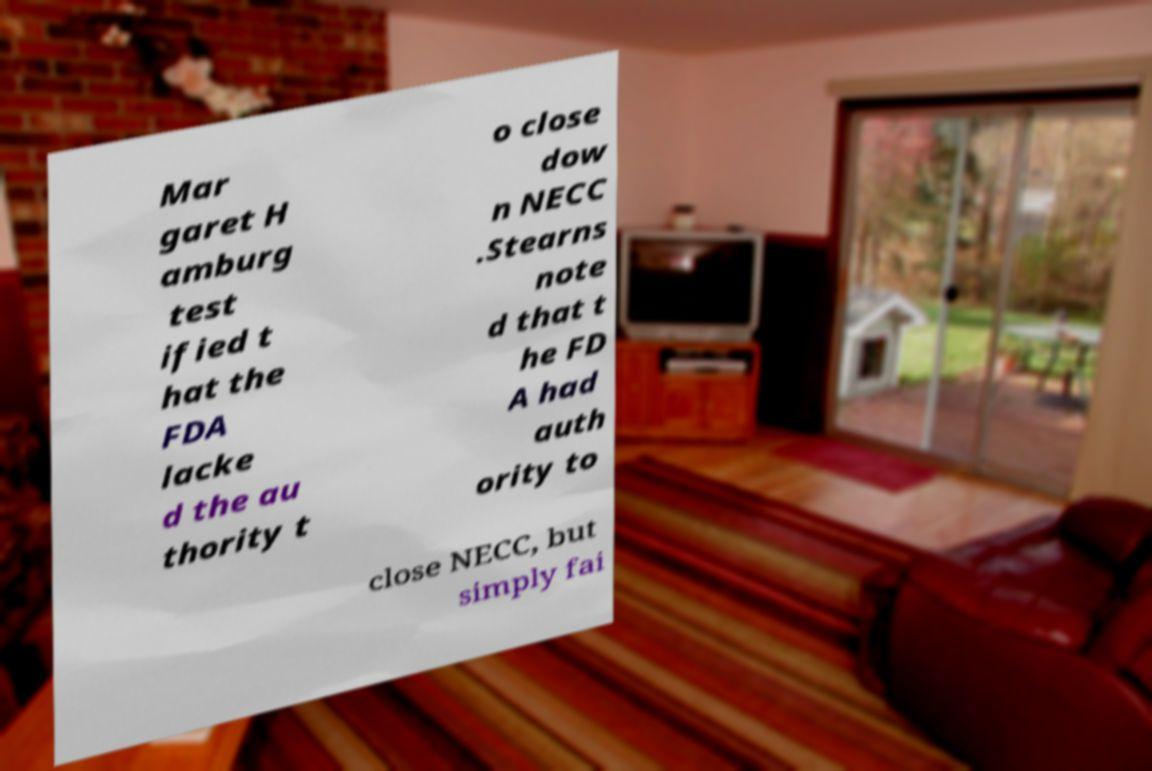Can you accurately transcribe the text from the provided image for me? Mar garet H amburg test ified t hat the FDA lacke d the au thority t o close dow n NECC .Stearns note d that t he FD A had auth ority to close NECC, but simply fai 